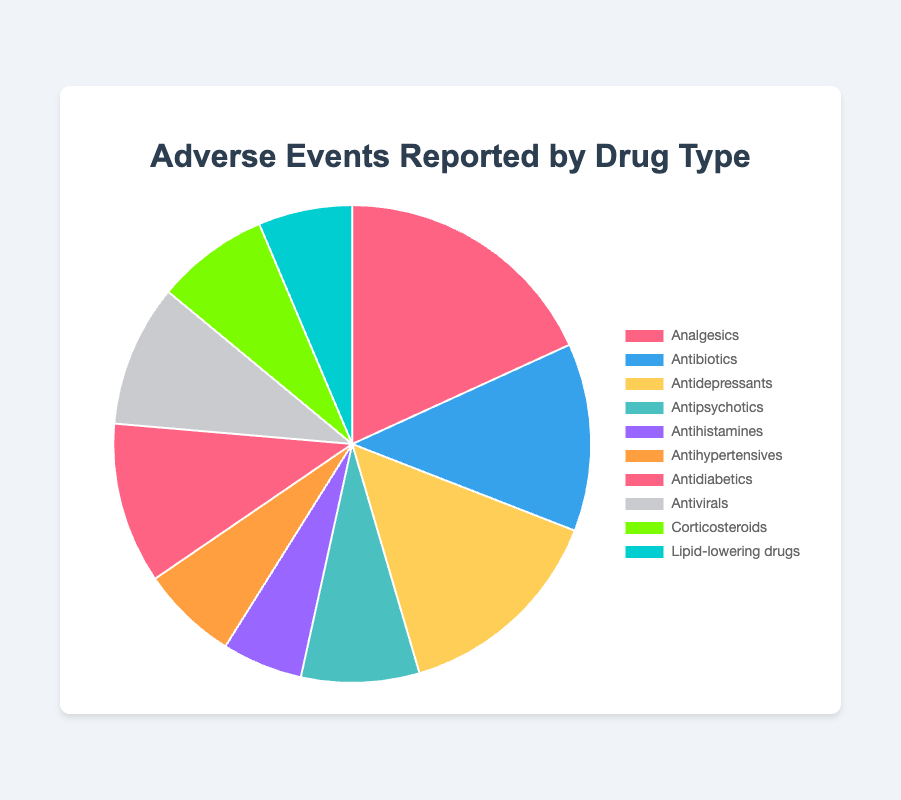Which drug type has the highest number of adverse events reported? Observing the pie chart, the segment representing Analgesics is the largest, indicating it has the highest number of adverse events reported.
Answer: Analgesics What's the total number of adverse events reported for Antipsychotics and Antidiabetics drugs? From the chart, Antipsychotics have 2200 and Antidiabetics have 3000 adverse events. Summing them, 2200 + 3000 = 5200.
Answer: 5200 Are there more adverse events reported for Antidepressants or Antibiotics? The chart shows Antidepressants have 4000 and Antibiotics have 3500 adverse events. Since 4000 > 3500, there are more adverse events reported for Antidepressants.
Answer: Antidepressants What percentage of the total adverse events is reported by Antivirals? Summing all adverse events: 5000 + 3500 + 4000 + 2200 + 1500 + 1800 + 3000 + 2650 + 2100 + 1750 = 27400. The percentage for Antivirals: (2650 / 27400) * 100 ≈ 9.67%.
Answer: 9.67% Which drug type has fewer adverse events reported, Corticosteroids or Lipid-lowering drugs? The pie chart shows Corticosteroids with 2100 and Lipid-lowering drugs with 1750 adverse events. Since 1750 < 2100, Lipid-lowering drugs have fewer adverse events reported.
Answer: Lipid-lowering drugs How does the number of adverse events for Antihistamines compare to those for Antihypertensives? From the pie chart, Antihistamines have 1500 and Antihypertensives have 1800 adverse events. Since 1500 < 1800, adverse events for Antihistamines are fewer than those for Antihypertensives.
Answer: Antihistamines have fewer What is the difference in adverse events between the drug with the most and the least reports? The most reported is Analgesics with 5000, and the least reported is Antihistamines with 1500. The difference is 5000 - 1500 = 3500.
Answer: 3500 Which color represents the segment for Antidepressants in the pie chart? The segment for Antidepressants is represented by the yellow color in the pie chart.
Answer: Yellow How many drug types have reported adverse events greater than 3000? Observing the pie chart, the drug types are Analgesics (5000), Antidepressants (4000), and Antidiabetics (3000). Only Analgesics and Antidepressants are greater than 3000. So, there are 2 drug types.
Answer: 2 